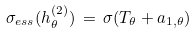Convert formula to latex. <formula><loc_0><loc_0><loc_500><loc_500>\sigma _ { e s s } ( h _ { \theta } ^ { ( 2 ) } ) \, = \, \sigma ( T _ { \theta } + a _ { 1 , \theta } )</formula> 